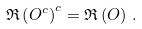Convert formula to latex. <formula><loc_0><loc_0><loc_500><loc_500>\mathfrak { R } \left ( O ^ { c } \right ) ^ { c } = \mathfrak { R } \left ( O \right ) \, .</formula> 